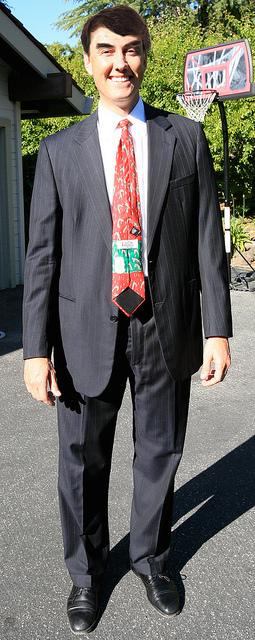Is the man's tie on right?
Be succinct. No. What is in the picture?
Keep it brief. Man. Is this man wearing glasses?
Short answer required. No. Is this man wearing a suit?
Write a very short answer. Yes. 